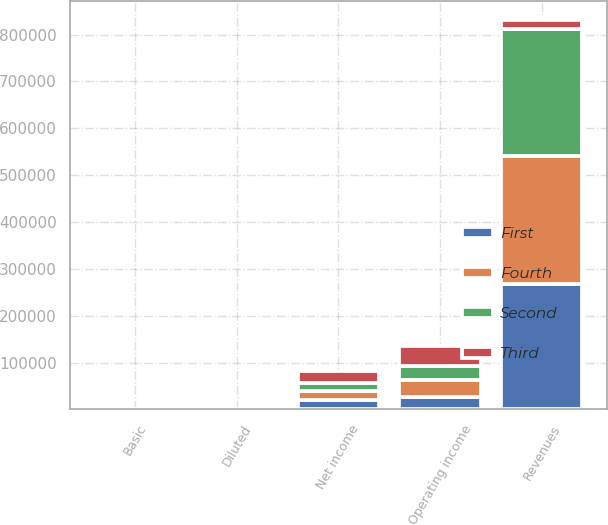<chart> <loc_0><loc_0><loc_500><loc_500><stacked_bar_chart><ecel><fcel>Revenues<fcel>Operating income<fcel>Net income<fcel>Basic<fcel>Diluted<nl><fcel>Fourth<fcel>273533<fcel>34451<fcel>19996<fcel>0.21<fcel>0.21<nl><fcel>Second<fcel>269971<fcel>30761<fcel>17185<fcel>0.18<fcel>0.18<nl><fcel>First<fcel>267469<fcel>27521<fcel>20067<fcel>0.21<fcel>0.21<nl><fcel>Third<fcel>19996<fcel>41744<fcel>25716<fcel>0.27<fcel>0.26<nl></chart> 